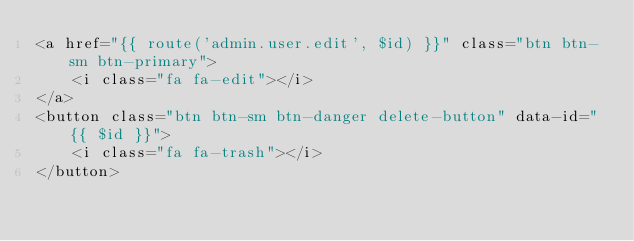Convert code to text. <code><loc_0><loc_0><loc_500><loc_500><_PHP_><a href="{{ route('admin.user.edit', $id) }}" class="btn btn-sm btn-primary">
    <i class="fa fa-edit"></i>
</a>
<button class="btn btn-sm btn-danger delete-button" data-id="{{ $id }}">
    <i class="fa fa-trash"></i>
</button></code> 